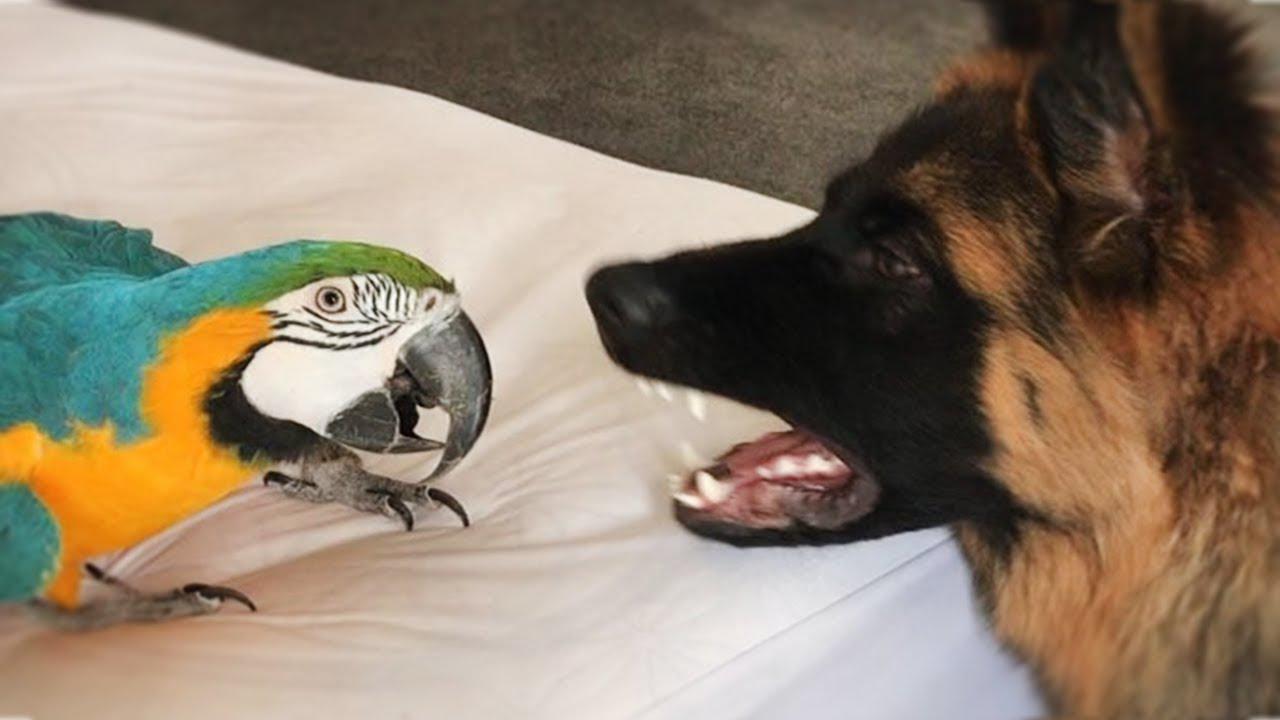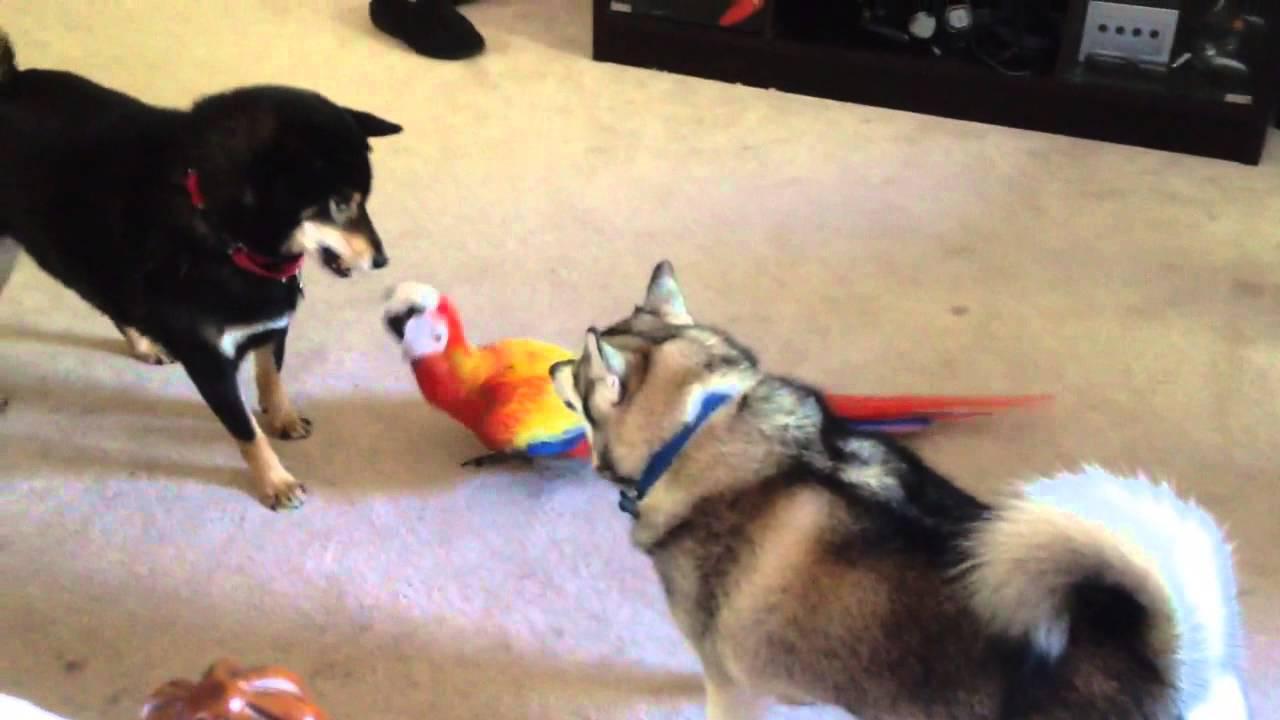The first image is the image on the left, the second image is the image on the right. Assess this claim about the two images: "There are two dogs and a macaw standing on carpet together in one image.". Correct or not? Answer yes or no. Yes. The first image is the image on the left, the second image is the image on the right. Considering the images on both sides, is "A german shepherd plays with a blue and gold macaw." valid? Answer yes or no. Yes. 